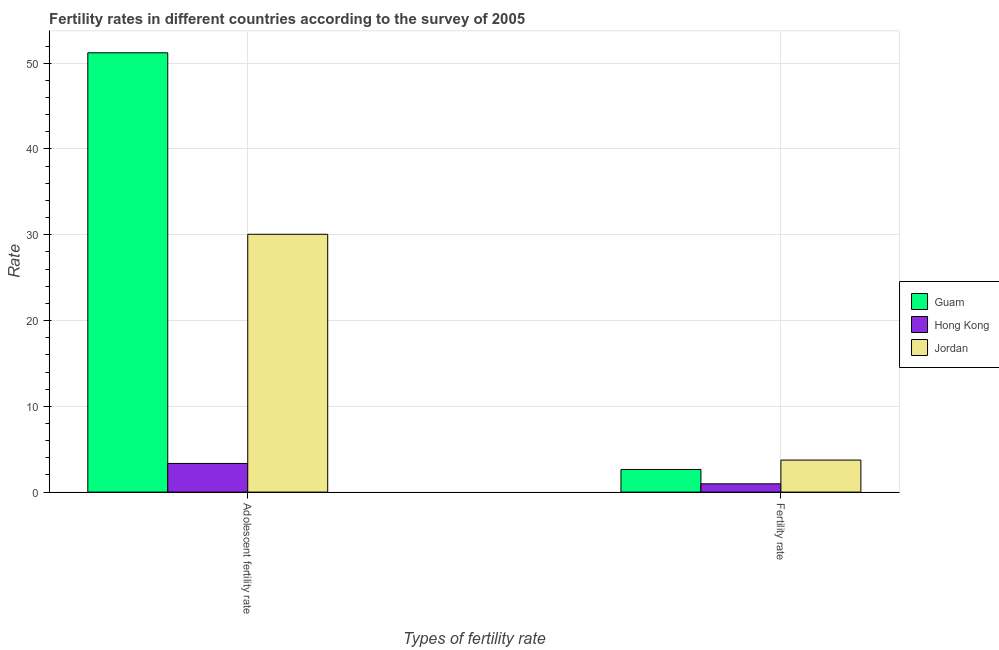How many groups of bars are there?
Your response must be concise. 2. Are the number of bars on each tick of the X-axis equal?
Give a very brief answer. Yes. How many bars are there on the 2nd tick from the right?
Provide a short and direct response. 3. What is the label of the 2nd group of bars from the left?
Offer a very short reply. Fertility rate. What is the adolescent fertility rate in Hong Kong?
Make the answer very short. 3.34. Across all countries, what is the maximum adolescent fertility rate?
Make the answer very short. 51.21. In which country was the fertility rate maximum?
Ensure brevity in your answer.  Jordan. In which country was the fertility rate minimum?
Provide a succinct answer. Hong Kong. What is the total adolescent fertility rate in the graph?
Your response must be concise. 84.61. What is the difference between the fertility rate in Jordan and that in Guam?
Your answer should be very brief. 1.1. What is the difference between the fertility rate in Hong Kong and the adolescent fertility rate in Guam?
Ensure brevity in your answer.  -50.25. What is the average adolescent fertility rate per country?
Make the answer very short. 28.2. What is the difference between the adolescent fertility rate and fertility rate in Jordan?
Keep it short and to the point. 26.32. What is the ratio of the fertility rate in Hong Kong to that in Guam?
Provide a succinct answer. 0.37. Is the adolescent fertility rate in Jordan less than that in Hong Kong?
Give a very brief answer. No. In how many countries, is the adolescent fertility rate greater than the average adolescent fertility rate taken over all countries?
Make the answer very short. 2. What does the 3rd bar from the left in Adolescent fertility rate represents?
Give a very brief answer. Jordan. What does the 2nd bar from the right in Fertility rate represents?
Make the answer very short. Hong Kong. How many bars are there?
Provide a short and direct response. 6. Does the graph contain any zero values?
Make the answer very short. No. How many legend labels are there?
Your answer should be very brief. 3. How are the legend labels stacked?
Your response must be concise. Vertical. What is the title of the graph?
Offer a very short reply. Fertility rates in different countries according to the survey of 2005. What is the label or title of the X-axis?
Your answer should be very brief. Types of fertility rate. What is the label or title of the Y-axis?
Your response must be concise. Rate. What is the Rate of Guam in Adolescent fertility rate?
Give a very brief answer. 51.21. What is the Rate of Hong Kong in Adolescent fertility rate?
Your answer should be compact. 3.34. What is the Rate in Jordan in Adolescent fertility rate?
Offer a terse response. 30.06. What is the Rate in Guam in Fertility rate?
Your answer should be compact. 2.64. What is the Rate of Hong Kong in Fertility rate?
Provide a short and direct response. 0.97. What is the Rate in Jordan in Fertility rate?
Your answer should be very brief. 3.73. Across all Types of fertility rate, what is the maximum Rate of Guam?
Give a very brief answer. 51.21. Across all Types of fertility rate, what is the maximum Rate of Hong Kong?
Provide a short and direct response. 3.34. Across all Types of fertility rate, what is the maximum Rate in Jordan?
Your answer should be very brief. 30.06. Across all Types of fertility rate, what is the minimum Rate in Guam?
Provide a succinct answer. 2.64. Across all Types of fertility rate, what is the minimum Rate of Hong Kong?
Provide a succinct answer. 0.97. Across all Types of fertility rate, what is the minimum Rate in Jordan?
Offer a very short reply. 3.73. What is the total Rate of Guam in the graph?
Your answer should be very brief. 53.85. What is the total Rate in Hong Kong in the graph?
Give a very brief answer. 4.31. What is the total Rate in Jordan in the graph?
Offer a terse response. 33.79. What is the difference between the Rate in Guam in Adolescent fertility rate and that in Fertility rate?
Give a very brief answer. 48.57. What is the difference between the Rate of Hong Kong in Adolescent fertility rate and that in Fertility rate?
Give a very brief answer. 2.37. What is the difference between the Rate in Jordan in Adolescent fertility rate and that in Fertility rate?
Your response must be concise. 26.32. What is the difference between the Rate of Guam in Adolescent fertility rate and the Rate of Hong Kong in Fertility rate?
Ensure brevity in your answer.  50.25. What is the difference between the Rate of Guam in Adolescent fertility rate and the Rate of Jordan in Fertility rate?
Provide a succinct answer. 47.48. What is the difference between the Rate in Hong Kong in Adolescent fertility rate and the Rate in Jordan in Fertility rate?
Provide a succinct answer. -0.39. What is the average Rate in Guam per Types of fertility rate?
Provide a short and direct response. 26.93. What is the average Rate of Hong Kong per Types of fertility rate?
Offer a terse response. 2.15. What is the average Rate of Jordan per Types of fertility rate?
Your answer should be very brief. 16.9. What is the difference between the Rate of Guam and Rate of Hong Kong in Adolescent fertility rate?
Your response must be concise. 47.87. What is the difference between the Rate in Guam and Rate in Jordan in Adolescent fertility rate?
Keep it short and to the point. 21.16. What is the difference between the Rate in Hong Kong and Rate in Jordan in Adolescent fertility rate?
Your answer should be very brief. -26.72. What is the difference between the Rate of Guam and Rate of Hong Kong in Fertility rate?
Offer a very short reply. 1.67. What is the difference between the Rate of Guam and Rate of Jordan in Fertility rate?
Offer a very short reply. -1.1. What is the difference between the Rate in Hong Kong and Rate in Jordan in Fertility rate?
Offer a terse response. -2.77. What is the ratio of the Rate of Guam in Adolescent fertility rate to that in Fertility rate?
Provide a short and direct response. 19.41. What is the ratio of the Rate in Hong Kong in Adolescent fertility rate to that in Fertility rate?
Provide a short and direct response. 3.46. What is the ratio of the Rate of Jordan in Adolescent fertility rate to that in Fertility rate?
Keep it short and to the point. 8.05. What is the difference between the highest and the second highest Rate in Guam?
Provide a succinct answer. 48.57. What is the difference between the highest and the second highest Rate of Hong Kong?
Your response must be concise. 2.37. What is the difference between the highest and the second highest Rate in Jordan?
Provide a succinct answer. 26.32. What is the difference between the highest and the lowest Rate in Guam?
Provide a short and direct response. 48.57. What is the difference between the highest and the lowest Rate in Hong Kong?
Offer a very short reply. 2.37. What is the difference between the highest and the lowest Rate of Jordan?
Provide a short and direct response. 26.32. 